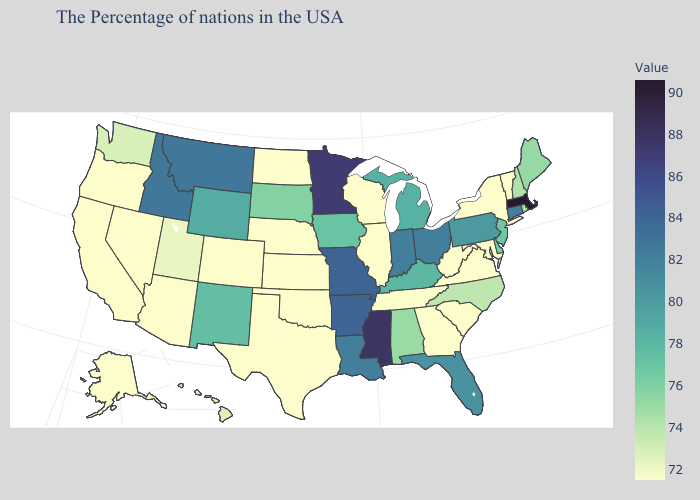Which states have the lowest value in the USA?
Write a very short answer. Vermont, New York, Maryland, Virginia, South Carolina, West Virginia, Georgia, Tennessee, Wisconsin, Illinois, Kansas, Nebraska, Oklahoma, Texas, North Dakota, Colorado, Arizona, Nevada, California, Oregon, Alaska. Does Maine have the highest value in the USA?
Short answer required. No. Which states have the lowest value in the West?
Be succinct. Colorado, Arizona, Nevada, California, Oregon, Alaska. Among the states that border Rhode Island , does Massachusetts have the highest value?
Give a very brief answer. Yes. Among the states that border Illinois , which have the lowest value?
Quick response, please. Wisconsin. 